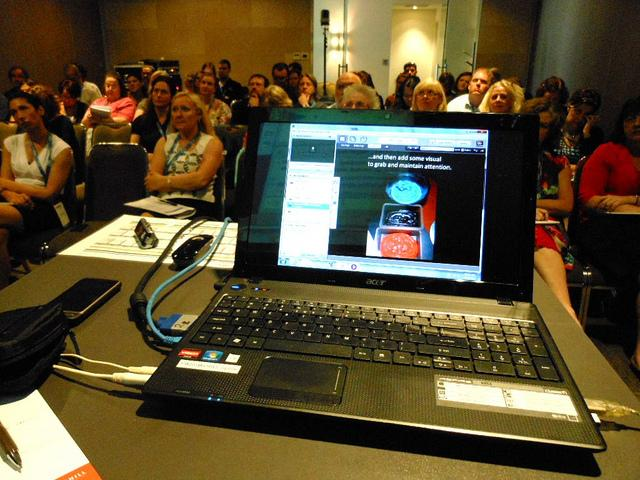What is the purpose of this event?

Choices:
A) relax
B) shop
C) learn
D) exercise learn 